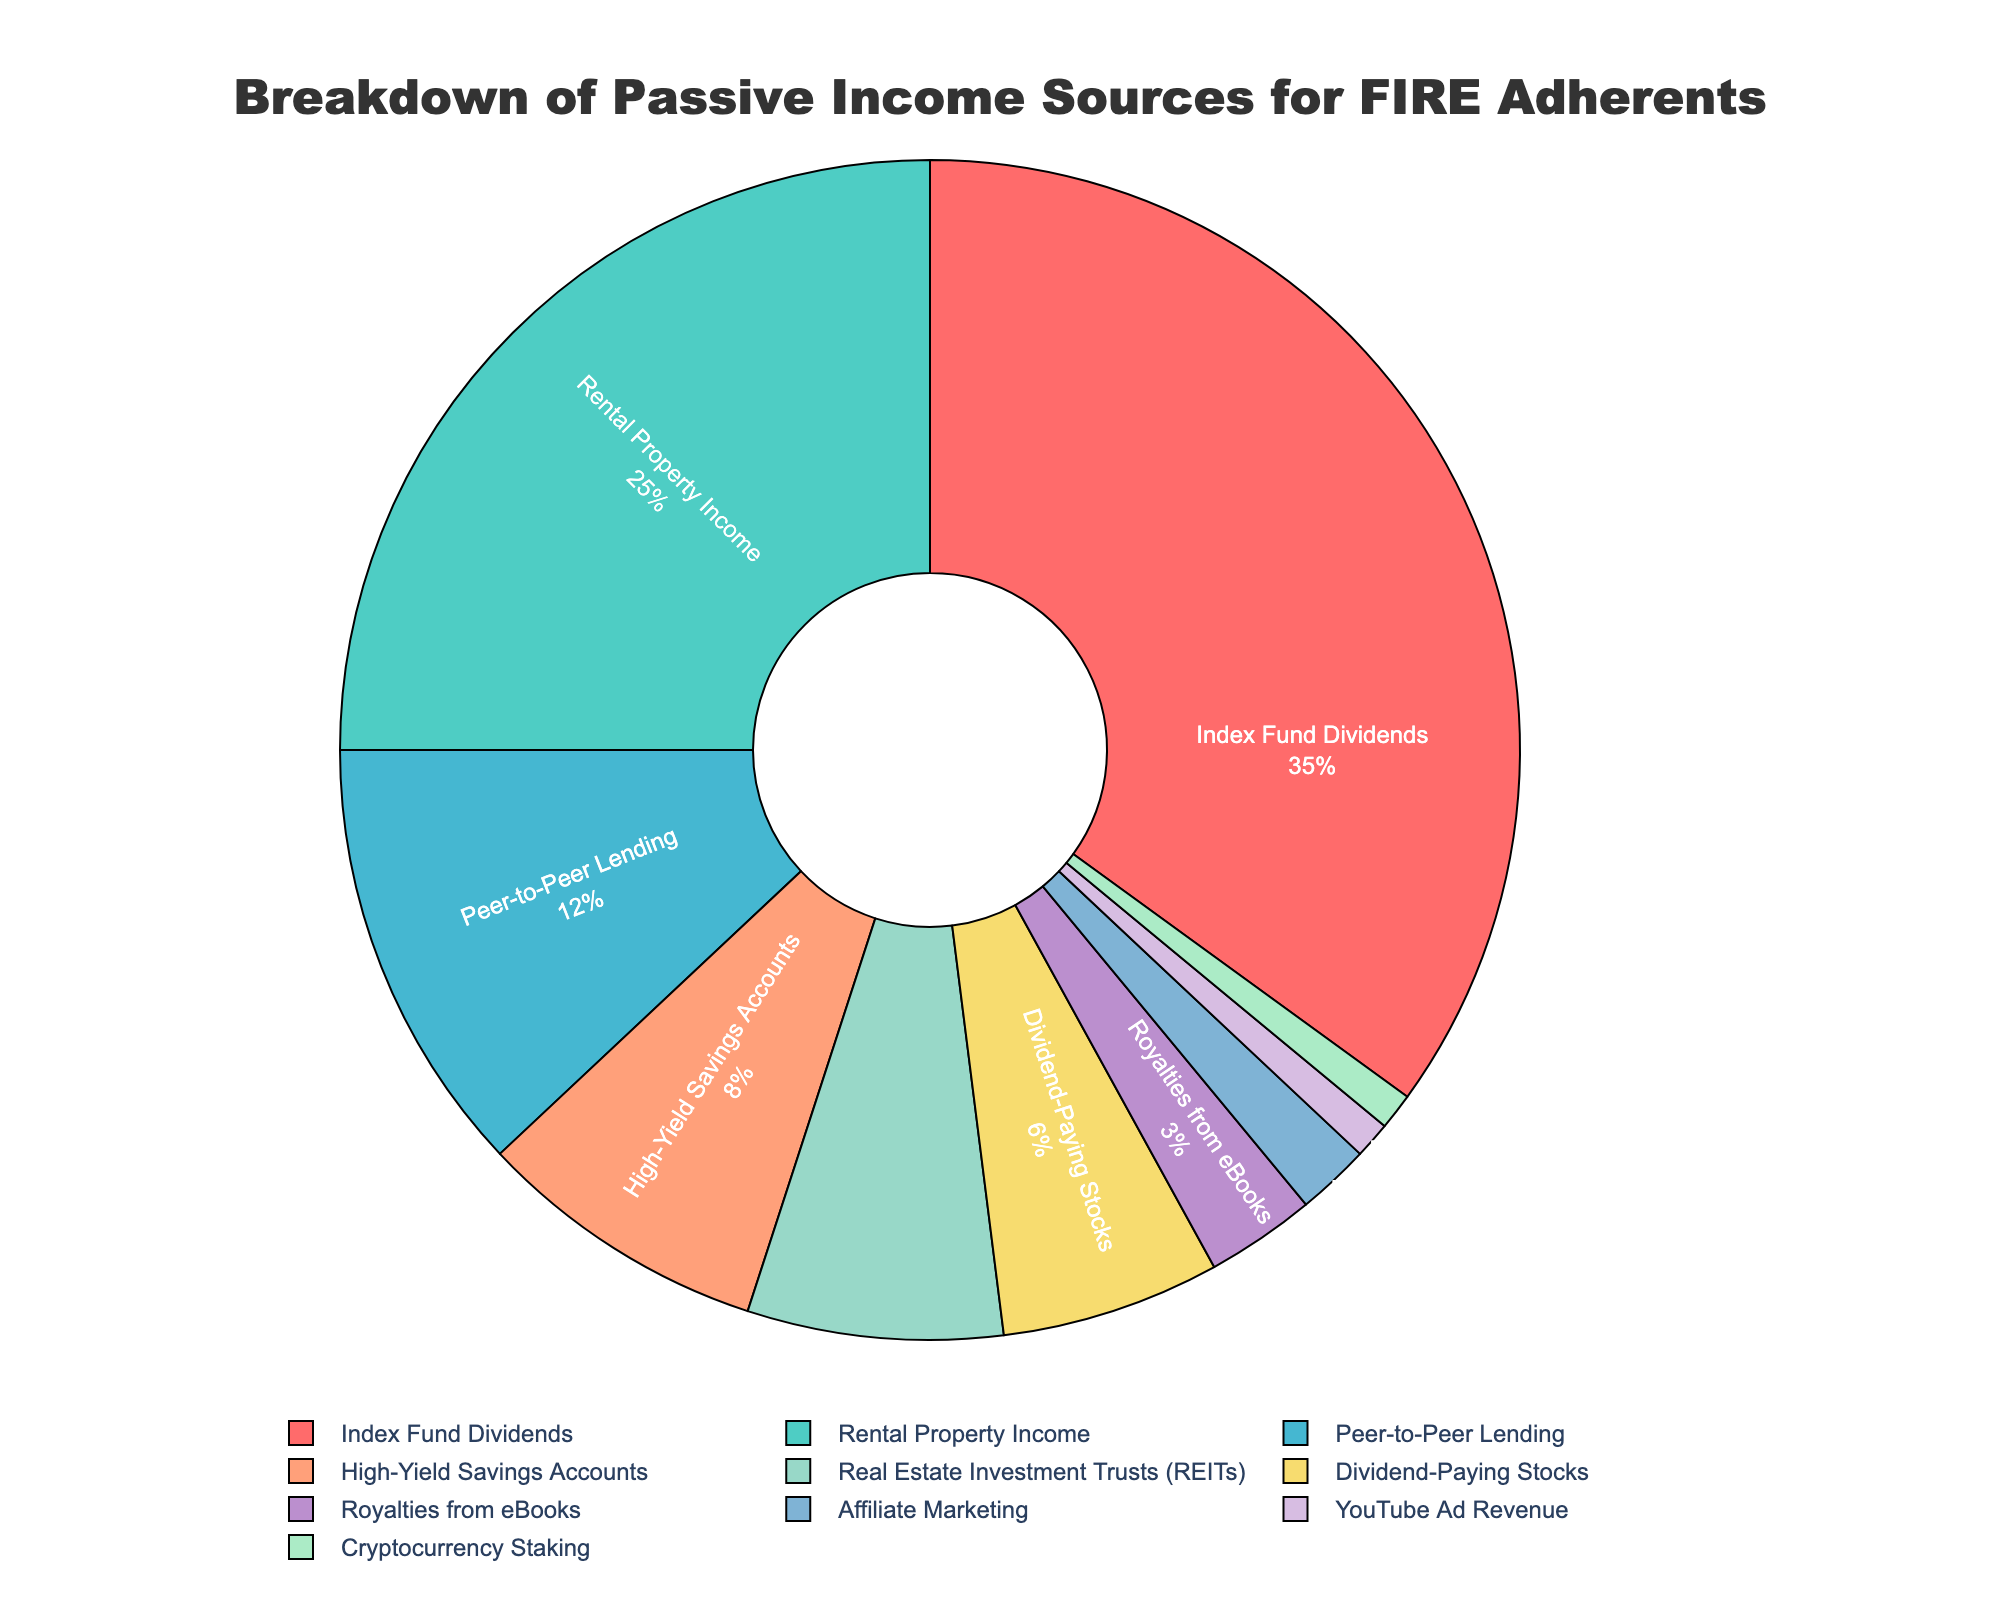Which passive income source has the highest percentage? By visual inspection of the pie chart, the largest segment corresponds to "Index Fund Dividends".
Answer: Index Fund Dividends Among "Rental Property Income" and "Peer-to-Peer Lending," which source contributes more to passive income? Looking at the sizes of the segments, "Rental Property Income" at 25% is larger than "Peer-to-Peer Lending" at 12%.
Answer: Rental Property Income Sum the percentages of the three largest passive income sources. The three largest sources are "Index Fund Dividends" (35%), "Rental Property Income" (25%), and "Peer-to-Peer Lending" (12%). Their sum is 35 + 25 + 12 = 72%.
Answer: 72% Which source contributes the least to passive income, and what is its percentage? By observing the smallest segment, "YouTube Ad Revenue" and "Cryptocurrency Staking" both contribute 1% each.
Answer: YouTube Ad Revenue, Cryptocurrency Staking How many sources contribute less than or equal to 5% of the total passive income? The segments "Royalties from eBooks" (3%), "Affiliate Marketing" (2%), "YouTube Ad Revenue" (1%), and "Cryptocurrency Staking" (1%) all meet this criterion, totaling to 4 sources.
Answer: 4 How much more does the largest income source contribute compared to the smallest source? The largest income source, "Index Fund Dividends," contributes 35%. The smallest sources, "YouTube Ad Revenue" and "Cryptocurrency Staking," each contribute 1%. The difference is 35 - 1 = 34%.
Answer: 34% What is the combined percentage contribution of "High-Yield Savings Accounts" and "Real Estate Investment Trusts (REITs)"? "High-Yield Savings Accounts" contribute 8% and "Real Estate Investment Trusts (REITs)" contribute 7%. Summing them up gives 8 + 7 = 15%.
Answer: 15% Which categories constitute less than 10% of the total passive income? From the pie chart, "Peer-to-Peer Lending" (12%), "High-Yield Savings Accounts" (8%), "Real Estate Investment Trusts (REITs)" (7%), "Dividend-Paying Stocks" (6%), "Royalties from eBooks" (3%), "Affiliate Marketing" (2%), "YouTube Ad Revenue" (1%), and "Cryptocurrency Staking" (1%) contribute less than 10%.
Answer: High-Yield Savings Accounts, Real Estate Investment Trusts (REITs), Dividend-Paying Stocks, Royalties from eBooks, Affiliate Marketing, YouTube Ad Revenue, Cryptocurrency Staking 